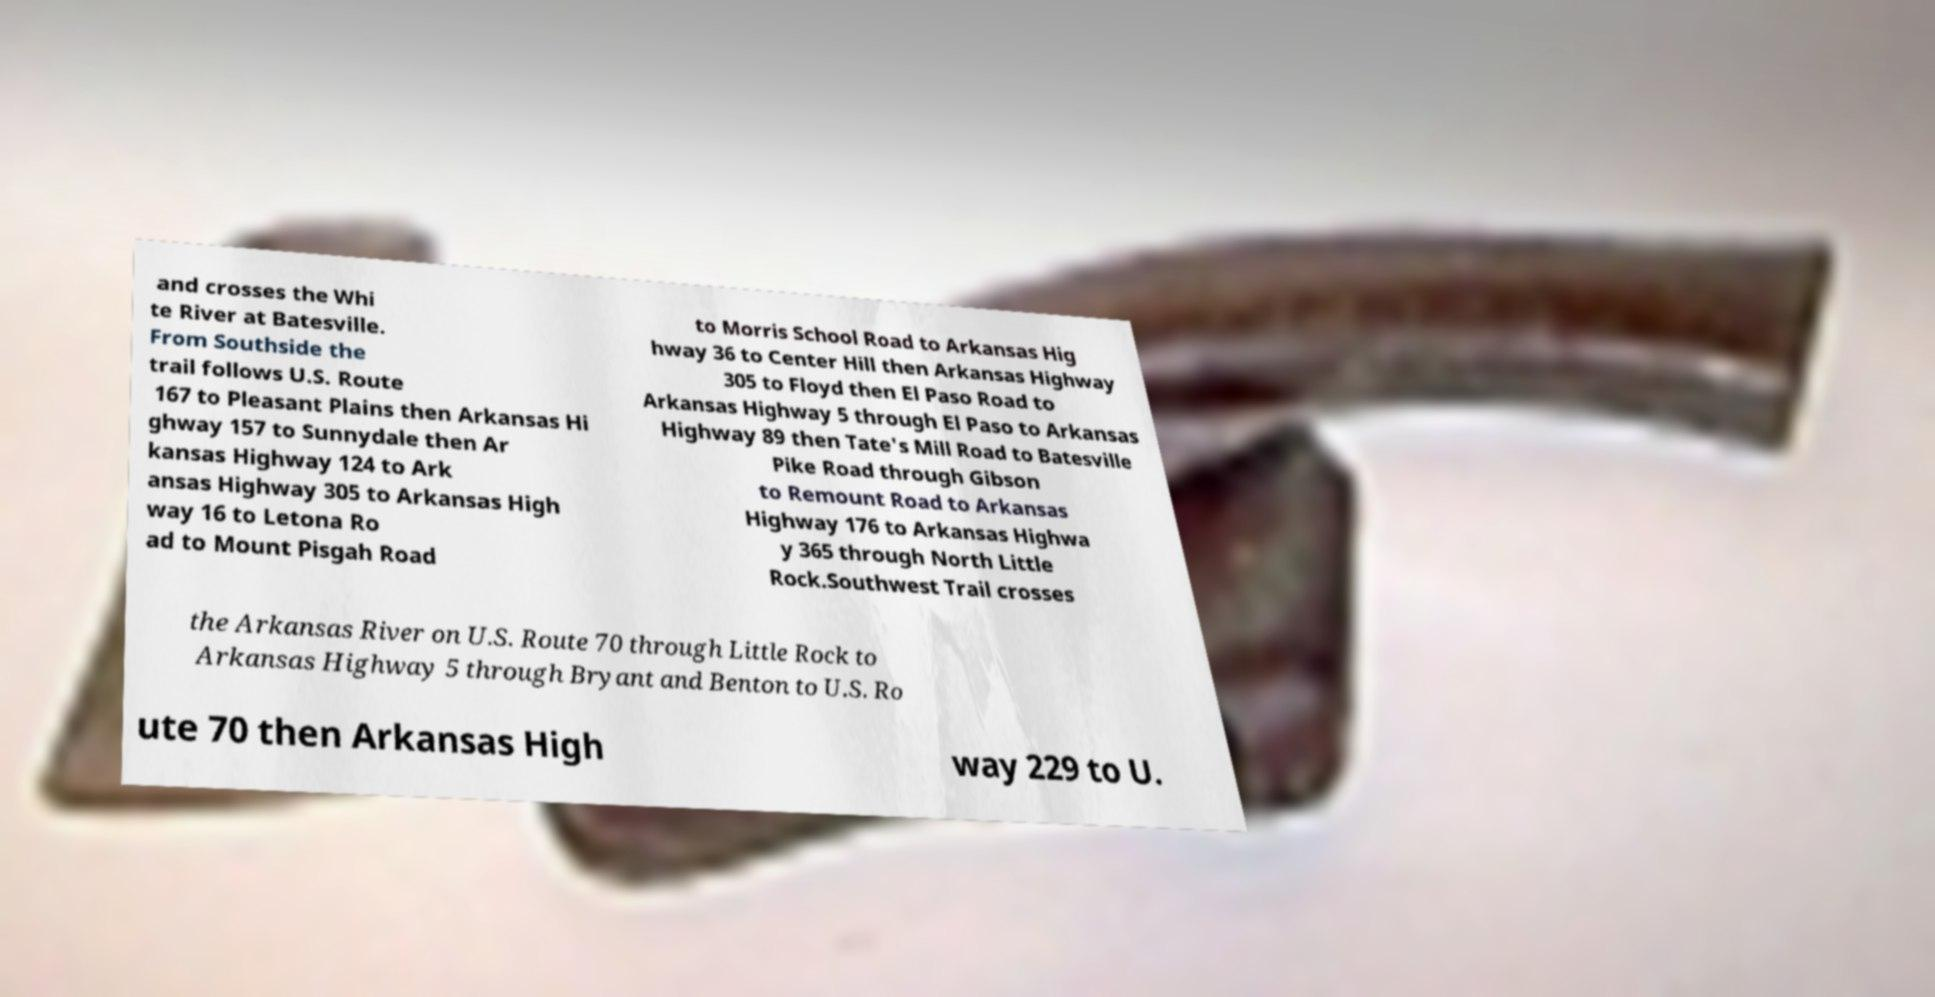Can you read and provide the text displayed in the image?This photo seems to have some interesting text. Can you extract and type it out for me? and crosses the Whi te River at Batesville. From Southside the trail follows U.S. Route 167 to Pleasant Plains then Arkansas Hi ghway 157 to Sunnydale then Ar kansas Highway 124 to Ark ansas Highway 305 to Arkansas High way 16 to Letona Ro ad to Mount Pisgah Road to Morris School Road to Arkansas Hig hway 36 to Center Hill then Arkansas Highway 305 to Floyd then El Paso Road to Arkansas Highway 5 through El Paso to Arkansas Highway 89 then Tate's Mill Road to Batesville Pike Road through Gibson to Remount Road to Arkansas Highway 176 to Arkansas Highwa y 365 through North Little Rock.Southwest Trail crosses the Arkansas River on U.S. Route 70 through Little Rock to Arkansas Highway 5 through Bryant and Benton to U.S. Ro ute 70 then Arkansas High way 229 to U. 